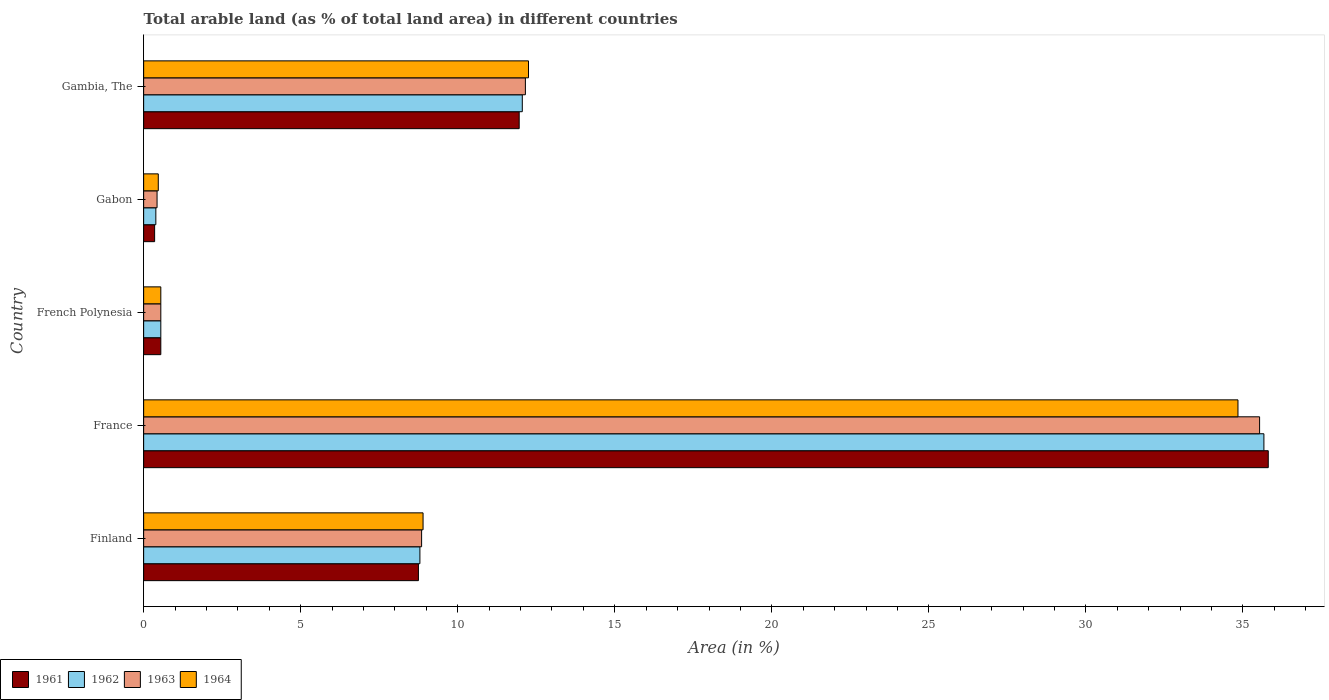How many groups of bars are there?
Offer a very short reply. 5. How many bars are there on the 2nd tick from the top?
Your answer should be compact. 4. In how many cases, is the number of bars for a given country not equal to the number of legend labels?
Your answer should be compact. 0. What is the percentage of arable land in 1962 in France?
Ensure brevity in your answer.  35.67. Across all countries, what is the maximum percentage of arable land in 1964?
Offer a terse response. 34.84. Across all countries, what is the minimum percentage of arable land in 1963?
Your answer should be very brief. 0.43. In which country was the percentage of arable land in 1963 minimum?
Provide a succinct answer. Gabon. What is the total percentage of arable land in 1963 in the graph?
Keep it short and to the point. 57.51. What is the difference between the percentage of arable land in 1961 in Finland and that in Gambia, The?
Your answer should be very brief. -3.21. What is the difference between the percentage of arable land in 1961 in France and the percentage of arable land in 1964 in Gambia, The?
Your response must be concise. 23.55. What is the average percentage of arable land in 1961 per country?
Provide a short and direct response. 11.48. What is the difference between the percentage of arable land in 1961 and percentage of arable land in 1962 in Finland?
Make the answer very short. -0.05. What is the ratio of the percentage of arable land in 1964 in Finland to that in France?
Your answer should be compact. 0.26. Is the percentage of arable land in 1962 in French Polynesia less than that in Gabon?
Your response must be concise. No. Is the difference between the percentage of arable land in 1961 in France and French Polynesia greater than the difference between the percentage of arable land in 1962 in France and French Polynesia?
Provide a succinct answer. Yes. What is the difference between the highest and the second highest percentage of arable land in 1962?
Offer a terse response. 23.61. What is the difference between the highest and the lowest percentage of arable land in 1963?
Your answer should be very brief. 35.1. Is the sum of the percentage of arable land in 1962 in Finland and France greater than the maximum percentage of arable land in 1964 across all countries?
Your response must be concise. Yes. Is it the case that in every country, the sum of the percentage of arable land in 1964 and percentage of arable land in 1963 is greater than the sum of percentage of arable land in 1962 and percentage of arable land in 1961?
Provide a short and direct response. No. What does the 1st bar from the top in Finland represents?
Your response must be concise. 1964. What does the 2nd bar from the bottom in French Polynesia represents?
Give a very brief answer. 1962. How many bars are there?
Make the answer very short. 20. Are all the bars in the graph horizontal?
Keep it short and to the point. Yes. What is the difference between two consecutive major ticks on the X-axis?
Offer a very short reply. 5. Are the values on the major ticks of X-axis written in scientific E-notation?
Ensure brevity in your answer.  No. Does the graph contain any zero values?
Your answer should be compact. No. Where does the legend appear in the graph?
Keep it short and to the point. Bottom left. How many legend labels are there?
Provide a succinct answer. 4. What is the title of the graph?
Offer a terse response. Total arable land (as % of total land area) in different countries. Does "1985" appear as one of the legend labels in the graph?
Keep it short and to the point. No. What is the label or title of the X-axis?
Offer a terse response. Area (in %). What is the Area (in %) in 1961 in Finland?
Provide a short and direct response. 8.75. What is the Area (in %) of 1962 in Finland?
Your response must be concise. 8.8. What is the Area (in %) in 1963 in Finland?
Give a very brief answer. 8.85. What is the Area (in %) in 1964 in Finland?
Offer a terse response. 8.9. What is the Area (in %) in 1961 in France?
Provide a short and direct response. 35.81. What is the Area (in %) of 1962 in France?
Give a very brief answer. 35.67. What is the Area (in %) in 1963 in France?
Your response must be concise. 35.53. What is the Area (in %) in 1964 in France?
Keep it short and to the point. 34.84. What is the Area (in %) in 1961 in French Polynesia?
Your response must be concise. 0.55. What is the Area (in %) in 1962 in French Polynesia?
Provide a short and direct response. 0.55. What is the Area (in %) of 1963 in French Polynesia?
Your answer should be very brief. 0.55. What is the Area (in %) in 1964 in French Polynesia?
Your answer should be very brief. 0.55. What is the Area (in %) of 1961 in Gabon?
Your response must be concise. 0.35. What is the Area (in %) in 1962 in Gabon?
Your answer should be compact. 0.39. What is the Area (in %) in 1963 in Gabon?
Offer a terse response. 0.43. What is the Area (in %) of 1964 in Gabon?
Give a very brief answer. 0.47. What is the Area (in %) in 1961 in Gambia, The?
Offer a terse response. 11.96. What is the Area (in %) in 1962 in Gambia, The?
Offer a terse response. 12.06. What is the Area (in %) in 1963 in Gambia, The?
Offer a very short reply. 12.15. What is the Area (in %) in 1964 in Gambia, The?
Keep it short and to the point. 12.25. Across all countries, what is the maximum Area (in %) in 1961?
Ensure brevity in your answer.  35.81. Across all countries, what is the maximum Area (in %) of 1962?
Make the answer very short. 35.67. Across all countries, what is the maximum Area (in %) of 1963?
Your answer should be very brief. 35.53. Across all countries, what is the maximum Area (in %) of 1964?
Offer a very short reply. 34.84. Across all countries, what is the minimum Area (in %) in 1961?
Make the answer very short. 0.35. Across all countries, what is the minimum Area (in %) of 1962?
Provide a succinct answer. 0.39. Across all countries, what is the minimum Area (in %) of 1963?
Offer a very short reply. 0.43. Across all countries, what is the minimum Area (in %) in 1964?
Ensure brevity in your answer.  0.47. What is the total Area (in %) of 1961 in the graph?
Make the answer very short. 57.41. What is the total Area (in %) of 1962 in the graph?
Your response must be concise. 57.45. What is the total Area (in %) in 1963 in the graph?
Keep it short and to the point. 57.51. What is the total Area (in %) of 1964 in the graph?
Make the answer very short. 57. What is the difference between the Area (in %) in 1961 in Finland and that in France?
Provide a succinct answer. -27.06. What is the difference between the Area (in %) of 1962 in Finland and that in France?
Ensure brevity in your answer.  -26.87. What is the difference between the Area (in %) in 1963 in Finland and that in France?
Offer a terse response. -26.68. What is the difference between the Area (in %) in 1964 in Finland and that in France?
Ensure brevity in your answer.  -25.95. What is the difference between the Area (in %) of 1961 in Finland and that in French Polynesia?
Give a very brief answer. 8.2. What is the difference between the Area (in %) in 1962 in Finland and that in French Polynesia?
Provide a succinct answer. 8.25. What is the difference between the Area (in %) of 1963 in Finland and that in French Polynesia?
Your answer should be compact. 8.3. What is the difference between the Area (in %) in 1964 in Finland and that in French Polynesia?
Your response must be concise. 8.35. What is the difference between the Area (in %) of 1961 in Finland and that in Gabon?
Offer a terse response. 8.4. What is the difference between the Area (in %) in 1962 in Finland and that in Gabon?
Keep it short and to the point. 8.41. What is the difference between the Area (in %) in 1963 in Finland and that in Gabon?
Provide a short and direct response. 8.42. What is the difference between the Area (in %) in 1964 in Finland and that in Gabon?
Your response must be concise. 8.43. What is the difference between the Area (in %) of 1961 in Finland and that in Gambia, The?
Offer a very short reply. -3.21. What is the difference between the Area (in %) in 1962 in Finland and that in Gambia, The?
Offer a very short reply. -3.26. What is the difference between the Area (in %) of 1963 in Finland and that in Gambia, The?
Keep it short and to the point. -3.3. What is the difference between the Area (in %) of 1964 in Finland and that in Gambia, The?
Provide a succinct answer. -3.36. What is the difference between the Area (in %) in 1961 in France and that in French Polynesia?
Give a very brief answer. 35.26. What is the difference between the Area (in %) in 1962 in France and that in French Polynesia?
Offer a terse response. 35.12. What is the difference between the Area (in %) of 1963 in France and that in French Polynesia?
Give a very brief answer. 34.98. What is the difference between the Area (in %) in 1964 in France and that in French Polynesia?
Ensure brevity in your answer.  34.3. What is the difference between the Area (in %) of 1961 in France and that in Gabon?
Give a very brief answer. 35.46. What is the difference between the Area (in %) of 1962 in France and that in Gabon?
Your response must be concise. 35.28. What is the difference between the Area (in %) in 1963 in France and that in Gabon?
Provide a short and direct response. 35.1. What is the difference between the Area (in %) in 1964 in France and that in Gabon?
Offer a very short reply. 34.38. What is the difference between the Area (in %) in 1961 in France and that in Gambia, The?
Offer a terse response. 23.85. What is the difference between the Area (in %) in 1962 in France and that in Gambia, The?
Keep it short and to the point. 23.61. What is the difference between the Area (in %) in 1963 in France and that in Gambia, The?
Keep it short and to the point. 23.38. What is the difference between the Area (in %) in 1964 in France and that in Gambia, The?
Make the answer very short. 22.59. What is the difference between the Area (in %) of 1961 in French Polynesia and that in Gabon?
Your answer should be compact. 0.2. What is the difference between the Area (in %) in 1962 in French Polynesia and that in Gabon?
Offer a very short reply. 0.16. What is the difference between the Area (in %) of 1963 in French Polynesia and that in Gabon?
Provide a succinct answer. 0.12. What is the difference between the Area (in %) in 1964 in French Polynesia and that in Gabon?
Keep it short and to the point. 0.08. What is the difference between the Area (in %) in 1961 in French Polynesia and that in Gambia, The?
Your answer should be very brief. -11.41. What is the difference between the Area (in %) of 1962 in French Polynesia and that in Gambia, The?
Offer a terse response. -11.51. What is the difference between the Area (in %) of 1963 in French Polynesia and that in Gambia, The?
Keep it short and to the point. -11.61. What is the difference between the Area (in %) of 1964 in French Polynesia and that in Gambia, The?
Give a very brief answer. -11.71. What is the difference between the Area (in %) of 1961 in Gabon and that in Gambia, The?
Your response must be concise. -11.61. What is the difference between the Area (in %) of 1962 in Gabon and that in Gambia, The?
Provide a succinct answer. -11.67. What is the difference between the Area (in %) in 1963 in Gabon and that in Gambia, The?
Your answer should be very brief. -11.73. What is the difference between the Area (in %) in 1964 in Gabon and that in Gambia, The?
Ensure brevity in your answer.  -11.79. What is the difference between the Area (in %) in 1961 in Finland and the Area (in %) in 1962 in France?
Provide a succinct answer. -26.92. What is the difference between the Area (in %) in 1961 in Finland and the Area (in %) in 1963 in France?
Your response must be concise. -26.78. What is the difference between the Area (in %) of 1961 in Finland and the Area (in %) of 1964 in France?
Give a very brief answer. -26.09. What is the difference between the Area (in %) of 1962 in Finland and the Area (in %) of 1963 in France?
Your answer should be compact. -26.73. What is the difference between the Area (in %) in 1962 in Finland and the Area (in %) in 1964 in France?
Provide a short and direct response. -26.05. What is the difference between the Area (in %) of 1963 in Finland and the Area (in %) of 1964 in France?
Your answer should be very brief. -25.99. What is the difference between the Area (in %) in 1961 in Finland and the Area (in %) in 1962 in French Polynesia?
Offer a terse response. 8.2. What is the difference between the Area (in %) in 1961 in Finland and the Area (in %) in 1963 in French Polynesia?
Provide a short and direct response. 8.2. What is the difference between the Area (in %) in 1961 in Finland and the Area (in %) in 1964 in French Polynesia?
Ensure brevity in your answer.  8.2. What is the difference between the Area (in %) of 1962 in Finland and the Area (in %) of 1963 in French Polynesia?
Make the answer very short. 8.25. What is the difference between the Area (in %) of 1962 in Finland and the Area (in %) of 1964 in French Polynesia?
Make the answer very short. 8.25. What is the difference between the Area (in %) of 1963 in Finland and the Area (in %) of 1964 in French Polynesia?
Provide a succinct answer. 8.3. What is the difference between the Area (in %) in 1961 in Finland and the Area (in %) in 1962 in Gabon?
Your answer should be compact. 8.36. What is the difference between the Area (in %) in 1961 in Finland and the Area (in %) in 1963 in Gabon?
Offer a terse response. 8.32. What is the difference between the Area (in %) in 1961 in Finland and the Area (in %) in 1964 in Gabon?
Your answer should be compact. 8.28. What is the difference between the Area (in %) of 1962 in Finland and the Area (in %) of 1963 in Gabon?
Offer a terse response. 8.37. What is the difference between the Area (in %) in 1962 in Finland and the Area (in %) in 1964 in Gabon?
Keep it short and to the point. 8.33. What is the difference between the Area (in %) in 1963 in Finland and the Area (in %) in 1964 in Gabon?
Provide a short and direct response. 8.38. What is the difference between the Area (in %) of 1961 in Finland and the Area (in %) of 1962 in Gambia, The?
Your answer should be very brief. -3.31. What is the difference between the Area (in %) of 1961 in Finland and the Area (in %) of 1963 in Gambia, The?
Provide a short and direct response. -3.41. What is the difference between the Area (in %) of 1961 in Finland and the Area (in %) of 1964 in Gambia, The?
Your answer should be very brief. -3.5. What is the difference between the Area (in %) of 1962 in Finland and the Area (in %) of 1963 in Gambia, The?
Provide a succinct answer. -3.36. What is the difference between the Area (in %) of 1962 in Finland and the Area (in %) of 1964 in Gambia, The?
Your answer should be very brief. -3.46. What is the difference between the Area (in %) of 1963 in Finland and the Area (in %) of 1964 in Gambia, The?
Make the answer very short. -3.4. What is the difference between the Area (in %) in 1961 in France and the Area (in %) in 1962 in French Polynesia?
Keep it short and to the point. 35.26. What is the difference between the Area (in %) in 1961 in France and the Area (in %) in 1963 in French Polynesia?
Keep it short and to the point. 35.26. What is the difference between the Area (in %) of 1961 in France and the Area (in %) of 1964 in French Polynesia?
Offer a terse response. 35.26. What is the difference between the Area (in %) in 1962 in France and the Area (in %) in 1963 in French Polynesia?
Ensure brevity in your answer.  35.12. What is the difference between the Area (in %) of 1962 in France and the Area (in %) of 1964 in French Polynesia?
Keep it short and to the point. 35.12. What is the difference between the Area (in %) of 1963 in France and the Area (in %) of 1964 in French Polynesia?
Give a very brief answer. 34.98. What is the difference between the Area (in %) of 1961 in France and the Area (in %) of 1962 in Gabon?
Provide a succinct answer. 35.42. What is the difference between the Area (in %) in 1961 in France and the Area (in %) in 1963 in Gabon?
Give a very brief answer. 35.38. What is the difference between the Area (in %) in 1961 in France and the Area (in %) in 1964 in Gabon?
Ensure brevity in your answer.  35.34. What is the difference between the Area (in %) of 1962 in France and the Area (in %) of 1963 in Gabon?
Make the answer very short. 35.24. What is the difference between the Area (in %) in 1962 in France and the Area (in %) in 1964 in Gabon?
Ensure brevity in your answer.  35.2. What is the difference between the Area (in %) in 1963 in France and the Area (in %) in 1964 in Gabon?
Your answer should be compact. 35.06. What is the difference between the Area (in %) in 1961 in France and the Area (in %) in 1962 in Gambia, The?
Ensure brevity in your answer.  23.75. What is the difference between the Area (in %) of 1961 in France and the Area (in %) of 1963 in Gambia, The?
Provide a succinct answer. 23.65. What is the difference between the Area (in %) of 1961 in France and the Area (in %) of 1964 in Gambia, The?
Keep it short and to the point. 23.55. What is the difference between the Area (in %) of 1962 in France and the Area (in %) of 1963 in Gambia, The?
Your answer should be compact. 23.51. What is the difference between the Area (in %) in 1962 in France and the Area (in %) in 1964 in Gambia, The?
Your response must be concise. 23.41. What is the difference between the Area (in %) of 1963 in France and the Area (in %) of 1964 in Gambia, The?
Keep it short and to the point. 23.28. What is the difference between the Area (in %) of 1961 in French Polynesia and the Area (in %) of 1962 in Gabon?
Offer a very short reply. 0.16. What is the difference between the Area (in %) in 1961 in French Polynesia and the Area (in %) in 1963 in Gabon?
Give a very brief answer. 0.12. What is the difference between the Area (in %) of 1961 in French Polynesia and the Area (in %) of 1964 in Gabon?
Your answer should be compact. 0.08. What is the difference between the Area (in %) of 1962 in French Polynesia and the Area (in %) of 1963 in Gabon?
Your answer should be compact. 0.12. What is the difference between the Area (in %) of 1962 in French Polynesia and the Area (in %) of 1964 in Gabon?
Ensure brevity in your answer.  0.08. What is the difference between the Area (in %) in 1963 in French Polynesia and the Area (in %) in 1964 in Gabon?
Provide a short and direct response. 0.08. What is the difference between the Area (in %) of 1961 in French Polynesia and the Area (in %) of 1962 in Gambia, The?
Give a very brief answer. -11.51. What is the difference between the Area (in %) in 1961 in French Polynesia and the Area (in %) in 1963 in Gambia, The?
Make the answer very short. -11.61. What is the difference between the Area (in %) in 1961 in French Polynesia and the Area (in %) in 1964 in Gambia, The?
Keep it short and to the point. -11.71. What is the difference between the Area (in %) of 1962 in French Polynesia and the Area (in %) of 1963 in Gambia, The?
Provide a succinct answer. -11.61. What is the difference between the Area (in %) of 1962 in French Polynesia and the Area (in %) of 1964 in Gambia, The?
Give a very brief answer. -11.71. What is the difference between the Area (in %) in 1963 in French Polynesia and the Area (in %) in 1964 in Gambia, The?
Offer a very short reply. -11.71. What is the difference between the Area (in %) of 1961 in Gabon and the Area (in %) of 1962 in Gambia, The?
Your response must be concise. -11.71. What is the difference between the Area (in %) in 1961 in Gabon and the Area (in %) in 1963 in Gambia, The?
Make the answer very short. -11.8. What is the difference between the Area (in %) in 1961 in Gabon and the Area (in %) in 1964 in Gambia, The?
Offer a terse response. -11.9. What is the difference between the Area (in %) in 1962 in Gabon and the Area (in %) in 1963 in Gambia, The?
Keep it short and to the point. -11.77. What is the difference between the Area (in %) in 1962 in Gabon and the Area (in %) in 1964 in Gambia, The?
Offer a terse response. -11.86. What is the difference between the Area (in %) of 1963 in Gabon and the Area (in %) of 1964 in Gambia, The?
Your response must be concise. -11.83. What is the average Area (in %) in 1961 per country?
Give a very brief answer. 11.48. What is the average Area (in %) in 1962 per country?
Give a very brief answer. 11.49. What is the average Area (in %) in 1963 per country?
Offer a terse response. 11.5. What is the average Area (in %) in 1964 per country?
Provide a succinct answer. 11.4. What is the difference between the Area (in %) in 1961 and Area (in %) in 1962 in Finland?
Your response must be concise. -0.05. What is the difference between the Area (in %) in 1961 and Area (in %) in 1963 in Finland?
Keep it short and to the point. -0.1. What is the difference between the Area (in %) in 1961 and Area (in %) in 1964 in Finland?
Keep it short and to the point. -0.15. What is the difference between the Area (in %) of 1962 and Area (in %) of 1963 in Finland?
Ensure brevity in your answer.  -0.05. What is the difference between the Area (in %) in 1962 and Area (in %) in 1964 in Finland?
Your answer should be compact. -0.1. What is the difference between the Area (in %) of 1963 and Area (in %) of 1964 in Finland?
Your answer should be very brief. -0.05. What is the difference between the Area (in %) in 1961 and Area (in %) in 1962 in France?
Offer a terse response. 0.14. What is the difference between the Area (in %) of 1961 and Area (in %) of 1963 in France?
Your response must be concise. 0.28. What is the difference between the Area (in %) in 1962 and Area (in %) in 1963 in France?
Offer a terse response. 0.14. What is the difference between the Area (in %) in 1962 and Area (in %) in 1964 in France?
Provide a short and direct response. 0.83. What is the difference between the Area (in %) in 1963 and Area (in %) in 1964 in France?
Your answer should be compact. 0.69. What is the difference between the Area (in %) in 1961 and Area (in %) in 1962 in French Polynesia?
Provide a succinct answer. 0. What is the difference between the Area (in %) in 1961 and Area (in %) in 1963 in French Polynesia?
Ensure brevity in your answer.  0. What is the difference between the Area (in %) in 1962 and Area (in %) in 1963 in French Polynesia?
Keep it short and to the point. 0. What is the difference between the Area (in %) of 1961 and Area (in %) of 1962 in Gabon?
Your answer should be very brief. -0.04. What is the difference between the Area (in %) of 1961 and Area (in %) of 1963 in Gabon?
Keep it short and to the point. -0.08. What is the difference between the Area (in %) of 1961 and Area (in %) of 1964 in Gabon?
Provide a succinct answer. -0.12. What is the difference between the Area (in %) in 1962 and Area (in %) in 1963 in Gabon?
Provide a succinct answer. -0.04. What is the difference between the Area (in %) of 1962 and Area (in %) of 1964 in Gabon?
Give a very brief answer. -0.08. What is the difference between the Area (in %) in 1963 and Area (in %) in 1964 in Gabon?
Ensure brevity in your answer.  -0.04. What is the difference between the Area (in %) of 1961 and Area (in %) of 1962 in Gambia, The?
Your answer should be very brief. -0.1. What is the difference between the Area (in %) in 1961 and Area (in %) in 1963 in Gambia, The?
Provide a short and direct response. -0.2. What is the difference between the Area (in %) of 1961 and Area (in %) of 1964 in Gambia, The?
Offer a terse response. -0.3. What is the difference between the Area (in %) of 1962 and Area (in %) of 1963 in Gambia, The?
Give a very brief answer. -0.1. What is the difference between the Area (in %) of 1962 and Area (in %) of 1964 in Gambia, The?
Provide a short and direct response. -0.2. What is the difference between the Area (in %) in 1963 and Area (in %) in 1964 in Gambia, The?
Offer a very short reply. -0.1. What is the ratio of the Area (in %) in 1961 in Finland to that in France?
Ensure brevity in your answer.  0.24. What is the ratio of the Area (in %) in 1962 in Finland to that in France?
Offer a terse response. 0.25. What is the ratio of the Area (in %) of 1963 in Finland to that in France?
Your answer should be compact. 0.25. What is the ratio of the Area (in %) in 1964 in Finland to that in France?
Offer a terse response. 0.26. What is the ratio of the Area (in %) in 1961 in Finland to that in French Polynesia?
Make the answer very short. 16.01. What is the ratio of the Area (in %) in 1962 in Finland to that in French Polynesia?
Keep it short and to the point. 16.1. What is the ratio of the Area (in %) of 1963 in Finland to that in French Polynesia?
Your answer should be compact. 16.19. What is the ratio of the Area (in %) in 1964 in Finland to that in French Polynesia?
Ensure brevity in your answer.  16.28. What is the ratio of the Area (in %) of 1961 in Finland to that in Gabon?
Keep it short and to the point. 25.05. What is the ratio of the Area (in %) of 1962 in Finland to that in Gabon?
Give a very brief answer. 22.66. What is the ratio of the Area (in %) in 1963 in Finland to that in Gabon?
Your response must be concise. 20.73. What is the ratio of the Area (in %) of 1964 in Finland to that in Gabon?
Keep it short and to the point. 19.1. What is the ratio of the Area (in %) of 1961 in Finland to that in Gambia, The?
Your answer should be very brief. 0.73. What is the ratio of the Area (in %) in 1962 in Finland to that in Gambia, The?
Provide a succinct answer. 0.73. What is the ratio of the Area (in %) of 1963 in Finland to that in Gambia, The?
Make the answer very short. 0.73. What is the ratio of the Area (in %) in 1964 in Finland to that in Gambia, The?
Provide a short and direct response. 0.73. What is the ratio of the Area (in %) in 1961 in France to that in French Polynesia?
Your answer should be very brief. 65.52. What is the ratio of the Area (in %) in 1962 in France to that in French Polynesia?
Make the answer very short. 65.27. What is the ratio of the Area (in %) of 1963 in France to that in French Polynesia?
Your answer should be compact. 65.02. What is the ratio of the Area (in %) in 1964 in France to that in French Polynesia?
Keep it short and to the point. 63.76. What is the ratio of the Area (in %) in 1961 in France to that in Gabon?
Give a very brief answer. 102.51. What is the ratio of the Area (in %) in 1962 in France to that in Gabon?
Provide a short and direct response. 91.9. What is the ratio of the Area (in %) of 1963 in France to that in Gabon?
Offer a very short reply. 83.23. What is the ratio of the Area (in %) in 1964 in France to that in Gabon?
Your answer should be compact. 74.81. What is the ratio of the Area (in %) of 1961 in France to that in Gambia, The?
Offer a terse response. 2.99. What is the ratio of the Area (in %) of 1962 in France to that in Gambia, The?
Your answer should be compact. 2.96. What is the ratio of the Area (in %) of 1963 in France to that in Gambia, The?
Your response must be concise. 2.92. What is the ratio of the Area (in %) in 1964 in France to that in Gambia, The?
Your response must be concise. 2.84. What is the ratio of the Area (in %) in 1961 in French Polynesia to that in Gabon?
Your response must be concise. 1.56. What is the ratio of the Area (in %) in 1962 in French Polynesia to that in Gabon?
Provide a succinct answer. 1.41. What is the ratio of the Area (in %) of 1963 in French Polynesia to that in Gabon?
Offer a terse response. 1.28. What is the ratio of the Area (in %) in 1964 in French Polynesia to that in Gabon?
Your response must be concise. 1.17. What is the ratio of the Area (in %) in 1961 in French Polynesia to that in Gambia, The?
Your response must be concise. 0.05. What is the ratio of the Area (in %) of 1962 in French Polynesia to that in Gambia, The?
Provide a succinct answer. 0.05. What is the ratio of the Area (in %) in 1963 in French Polynesia to that in Gambia, The?
Give a very brief answer. 0.04. What is the ratio of the Area (in %) of 1964 in French Polynesia to that in Gambia, The?
Your response must be concise. 0.04. What is the ratio of the Area (in %) in 1961 in Gabon to that in Gambia, The?
Your answer should be very brief. 0.03. What is the ratio of the Area (in %) of 1962 in Gabon to that in Gambia, The?
Your response must be concise. 0.03. What is the ratio of the Area (in %) of 1963 in Gabon to that in Gambia, The?
Offer a terse response. 0.04. What is the ratio of the Area (in %) of 1964 in Gabon to that in Gambia, The?
Your response must be concise. 0.04. What is the difference between the highest and the second highest Area (in %) of 1961?
Keep it short and to the point. 23.85. What is the difference between the highest and the second highest Area (in %) in 1962?
Your response must be concise. 23.61. What is the difference between the highest and the second highest Area (in %) in 1963?
Keep it short and to the point. 23.38. What is the difference between the highest and the second highest Area (in %) of 1964?
Ensure brevity in your answer.  22.59. What is the difference between the highest and the lowest Area (in %) of 1961?
Provide a succinct answer. 35.46. What is the difference between the highest and the lowest Area (in %) of 1962?
Make the answer very short. 35.28. What is the difference between the highest and the lowest Area (in %) in 1963?
Offer a very short reply. 35.1. What is the difference between the highest and the lowest Area (in %) of 1964?
Provide a short and direct response. 34.38. 